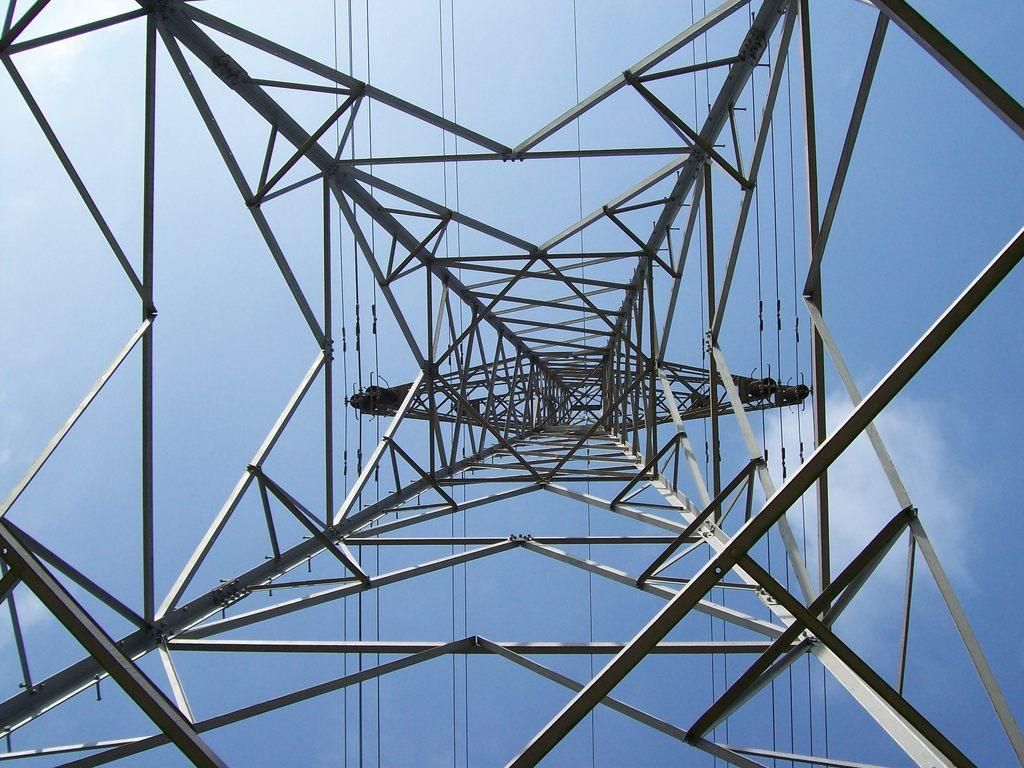What is the main structure in the image? There is a tower in the image. What is the tower made of? The tower is made of rods. What else can be seen in the image besides the tower? There are wires visible in the image. What is the color of the sky in the image? The sky is blue and white in color. What unit of measurement is used to determine the interest rate in the image? There is no mention of interest rates or any financial context in the image, so this question cannot be answered definitively. 